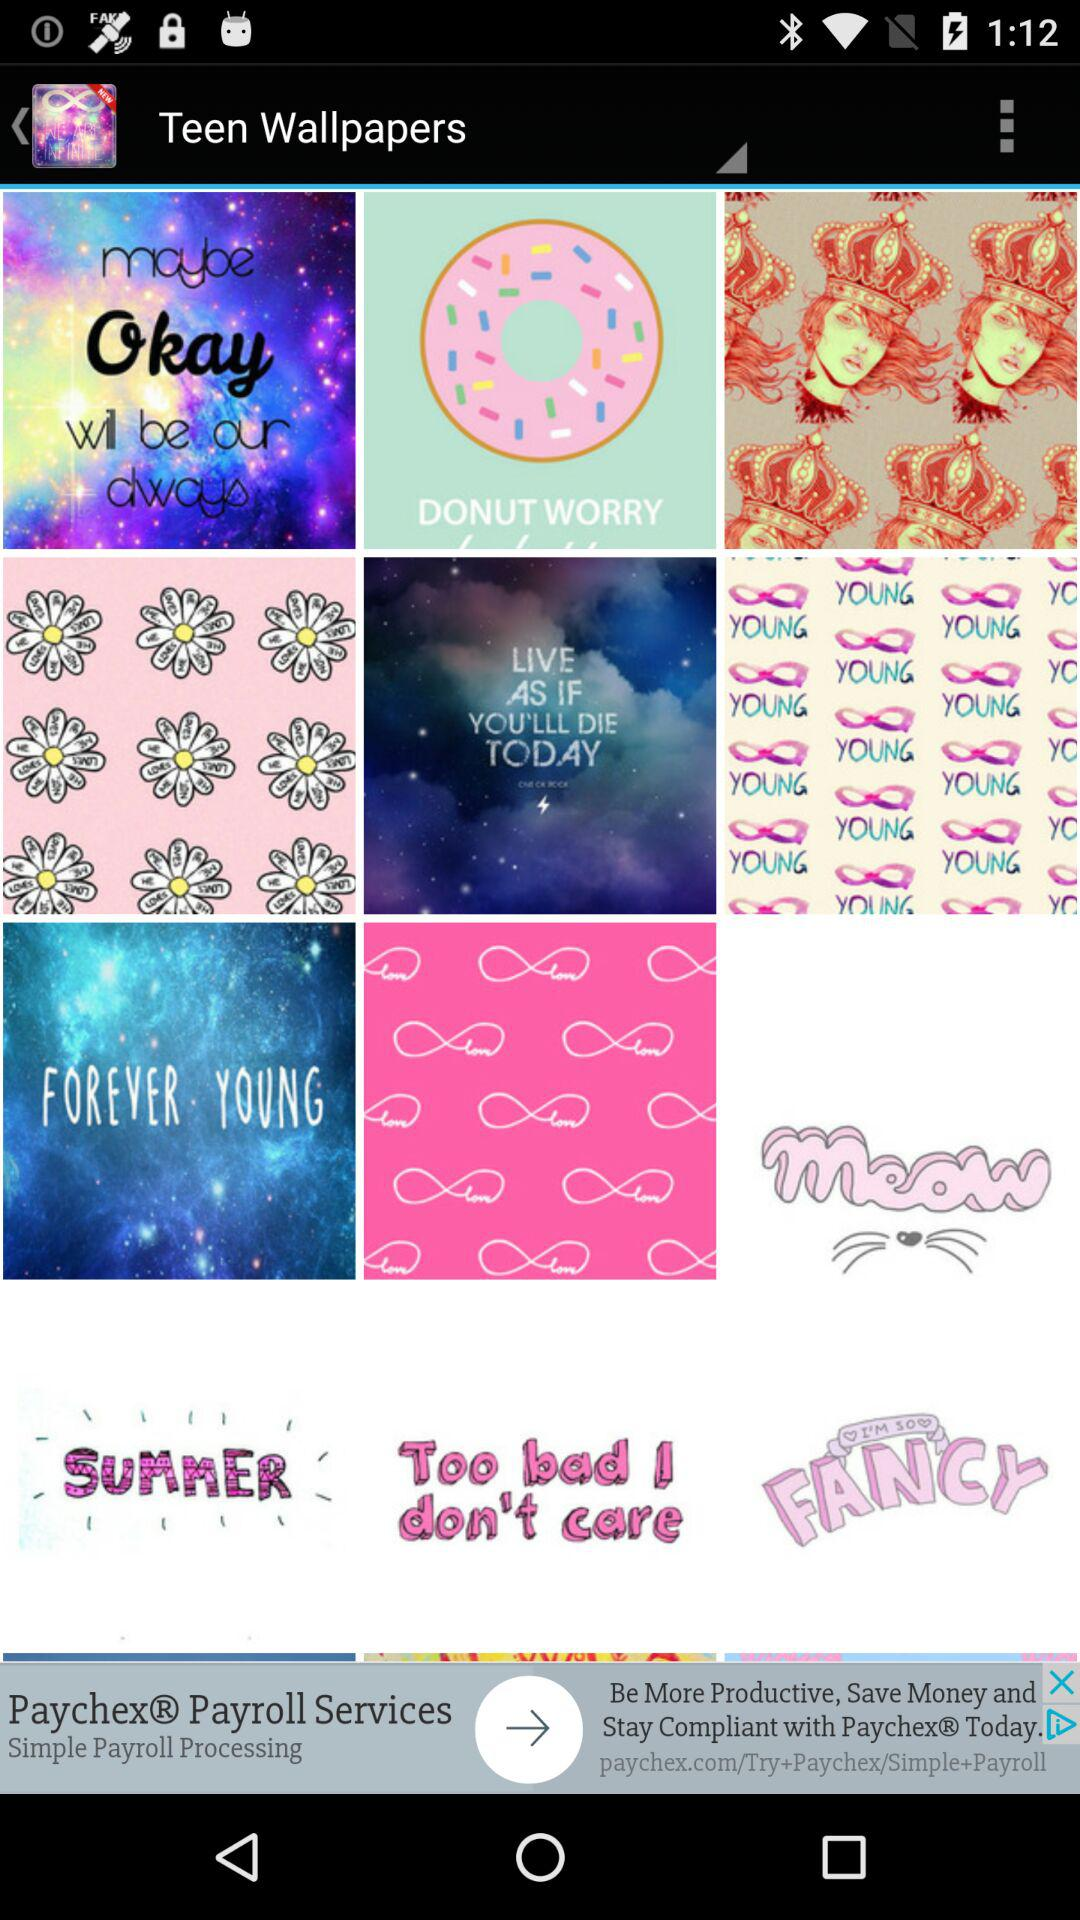What is the selected wallpaper? The selected wallpaper is "Teen Wallpapers". 